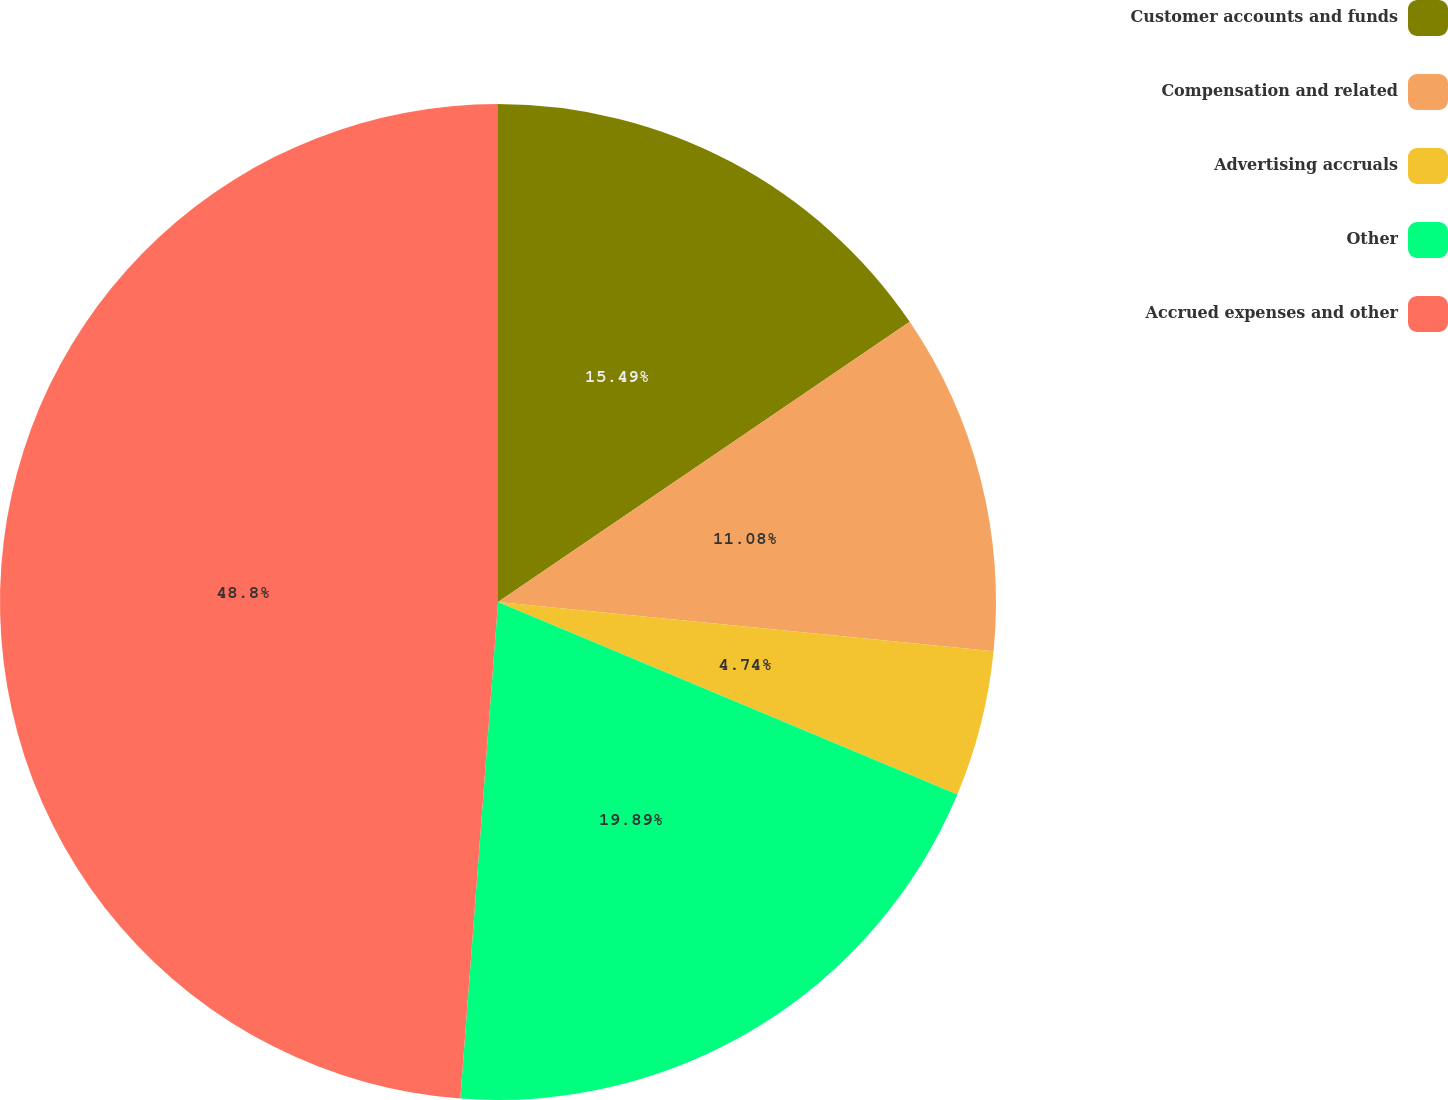Convert chart to OTSL. <chart><loc_0><loc_0><loc_500><loc_500><pie_chart><fcel>Customer accounts and funds<fcel>Compensation and related<fcel>Advertising accruals<fcel>Other<fcel>Accrued expenses and other<nl><fcel>15.49%<fcel>11.08%<fcel>4.74%<fcel>19.89%<fcel>48.79%<nl></chart> 